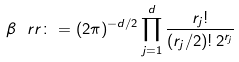<formula> <loc_0><loc_0><loc_500><loc_500>\beta _ { \ } r r \colon = ( 2 \pi ) ^ { - d / 2 } \prod _ { j = 1 } ^ { d } \frac { r _ { j } ! } { ( r _ { j } / 2 ) ! \, 2 ^ { r _ { j } } }</formula> 